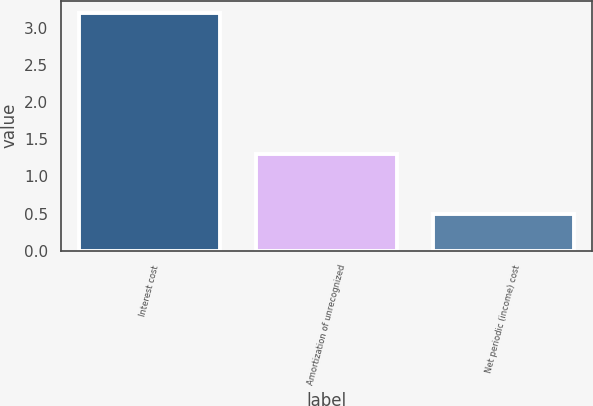Convert chart to OTSL. <chart><loc_0><loc_0><loc_500><loc_500><bar_chart><fcel>Interest cost<fcel>Amortization of unrecognized<fcel>Net periodic (income) cost<nl><fcel>3.2<fcel>1.3<fcel>0.5<nl></chart> 